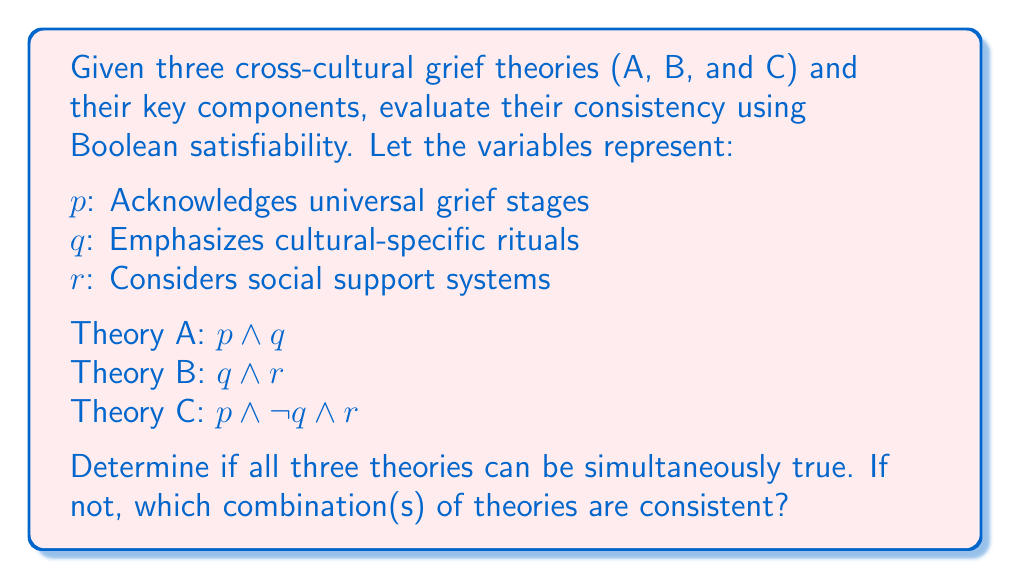Help me with this question. To evaluate the consistency of these theories using Boolean satisfiability, we need to determine if there exists a truth assignment that satisfies all three theories simultaneously.

1. Combine the theories into a single Boolean expression:
   $$(p \land q) \land (q \land r) \land (p \land \lnot q \land r)$$

2. Simplify the expression:
   $p \land q \land r \land \lnot q$

3. Analyze the simplified expression:
   - We have both $q$ and $\lnot q$, which is a contradiction.
   - This means all three theories cannot be simultaneously true.

4. Evaluate pairs of theories:
   a) A and B: $(p \land q) \land (q \land r)$ simplifies to $p \land q \land r$ (consistent)
   b) A and C: $(p \land q) \land (p \land \lnot q \land r)$ contains $q \land \lnot q$ (inconsistent)
   c) B and C: $(q \land r) \land (p \land \lnot q \land r)$ contains $q \land \lnot q$ (inconsistent)

5. Evaluate individual theories:
   Each theory is internally consistent.

Therefore, theories A and B are consistent with each other, but theory C is inconsistent with both A and B individually.
Answer: A and B consistent; C inconsistent with A and B 